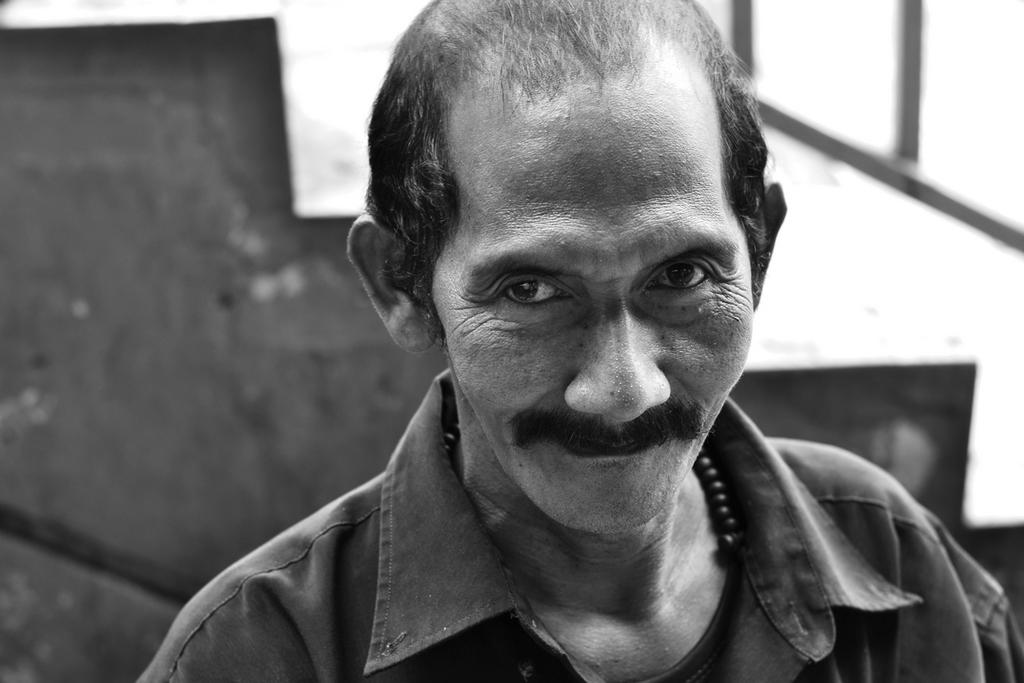What is the color scheme of the image? The image is black and white. Who is present in the image? There is a man in the image. What is the man wearing? The man is wearing a shirt. What architectural feature can be seen in the image? There are stairs visible in the image. How many houses are visible in the image? There are no houses visible in the image; it only features a man and stairs. What type of lizards can be seen crawling on the man's shirt in the image? There are no lizards present in the image; the man is wearing a shirt, but no lizards are visible. 